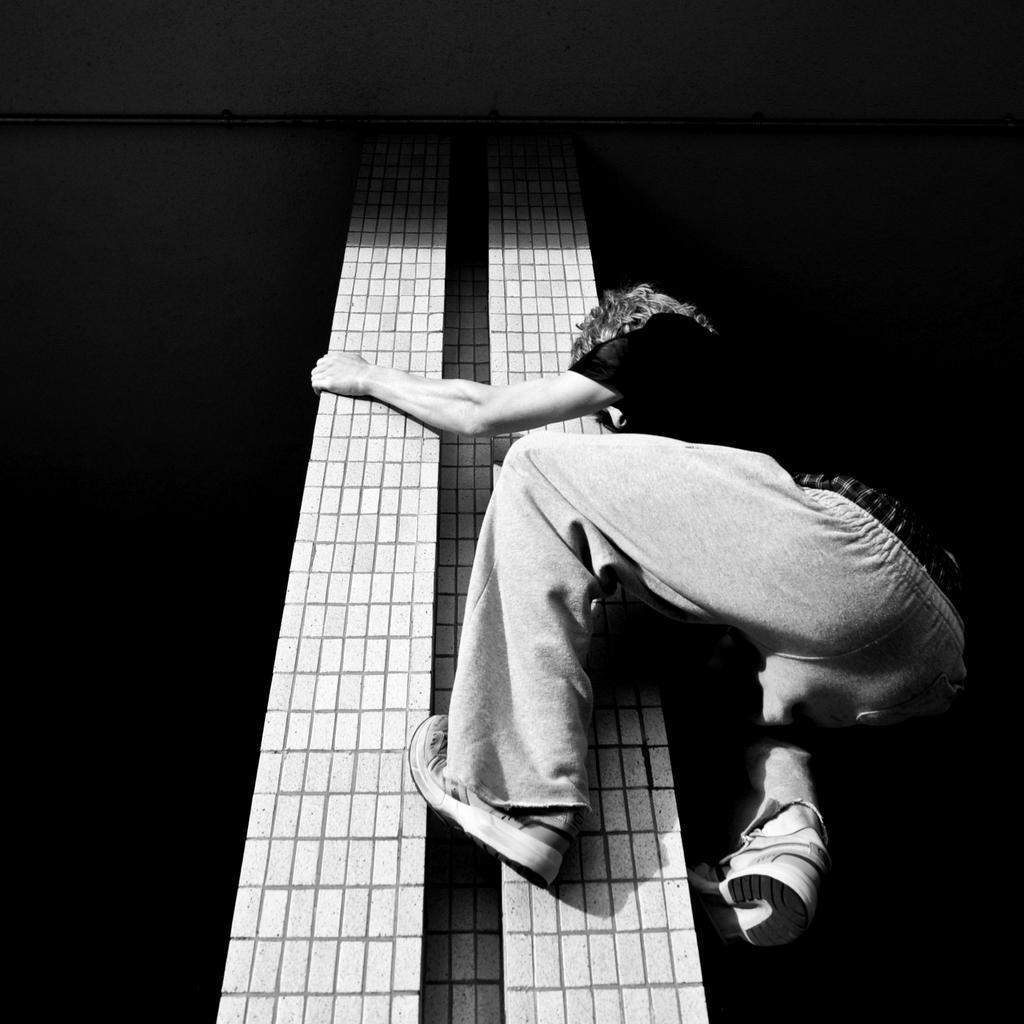Describe this image in one or two sentences. In this image I can see the person with the dress and the person is climbing the pillar. I can see this is a black and white image. 